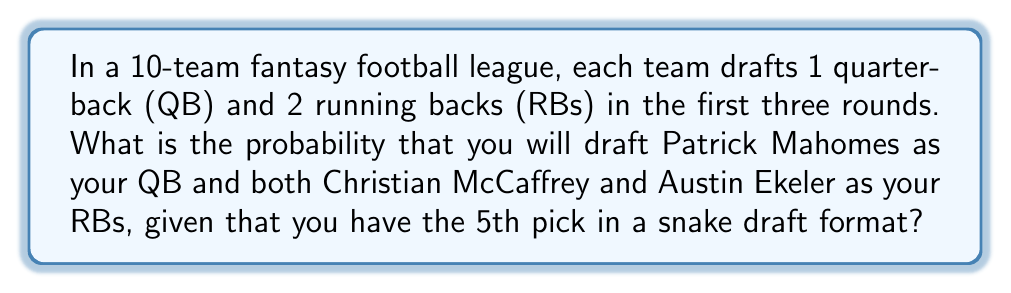Provide a solution to this math problem. Let's break this down step-by-step:

1) In a snake draft with 10 teams, you have the 5th, 16th, and 25th picks in the first three rounds.

2) For Mahomes to be your QB, he must be available at your 5th pick, and you must choose him. The probability of him being available is:

   $P(\text{Mahomes available}) = \frac{6}{10} = 0.6$ (he must not be picked in the first 4 picks)

3) For McCaffrey and Ekeler to be your RBs, they must both be available at your 16th and 25th picks, and you must choose them. Let's calculate the probability of them both being available:

   $P(\text{McCaffrey available at 16th}) = \frac{15}{30} = 0.5$ (15 players out of 30 remaining must not be McCaffrey)
   
   $P(\text{Ekeler available at 25th}) = \frac{24}{29} \approx 0.8276$ (24 players out of 29 remaining must not be Ekeler)

4) The probability of all these independent events occurring together is the product of their individual probabilities:

   $P(\text{all events}) = 0.6 \times 0.5 \times 0.8276 \approx 0.2483$

5) However, this assumes you will definitely pick these players if they're available. In reality, you have to choose to draft them. Assuming you're equally likely to pick any available player:

   $P(\text{choosing Mahomes}) = \frac{1}{6}$ (1 out of 6 available QBs)
   $P(\text{choosing McCaffrey}) = \frac{1}{15}$ (1 out of 15 available players)
   $P(\text{choosing Ekeler}) = \frac{1}{24}$ (1 out of 24 available players)

6) The final probability is:

   $P(\text{final}) = 0.6 \times \frac{1}{6} \times 0.5 \times \frac{1}{15} \times 0.8276 \times \frac{1}{24} \approx 0.000115$
Answer: The probability is approximately $0.000115$ or about $0.0115\%$. 